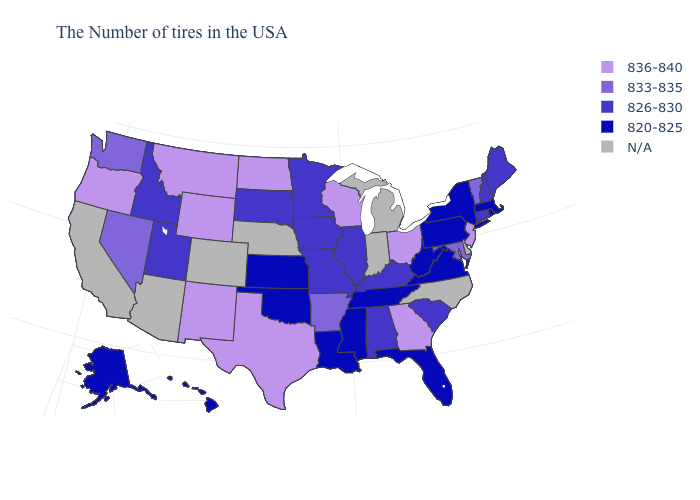Name the states that have a value in the range 826-830?
Be succinct. Maine, New Hampshire, Connecticut, South Carolina, Kentucky, Alabama, Illinois, Missouri, Minnesota, Iowa, South Dakota, Utah, Idaho. What is the value of Connecticut?
Write a very short answer. 826-830. Does Rhode Island have the lowest value in the USA?
Keep it brief. Yes. Name the states that have a value in the range 833-835?
Quick response, please. Vermont, Maryland, Arkansas, Nevada, Washington. What is the value of Indiana?
Short answer required. N/A. Name the states that have a value in the range N/A?
Give a very brief answer. Delaware, North Carolina, Michigan, Indiana, Nebraska, Colorado, Arizona, California. Does the map have missing data?
Answer briefly. Yes. Name the states that have a value in the range 826-830?
Short answer required. Maine, New Hampshire, Connecticut, South Carolina, Kentucky, Alabama, Illinois, Missouri, Minnesota, Iowa, South Dakota, Utah, Idaho. What is the lowest value in the USA?
Quick response, please. 820-825. Among the states that border Nevada , which have the lowest value?
Quick response, please. Utah, Idaho. Among the states that border Tennessee , which have the lowest value?
Concise answer only. Virginia, Mississippi. Does Nevada have the highest value in the USA?
Concise answer only. No. Name the states that have a value in the range N/A?
Quick response, please. Delaware, North Carolina, Michigan, Indiana, Nebraska, Colorado, Arizona, California. 